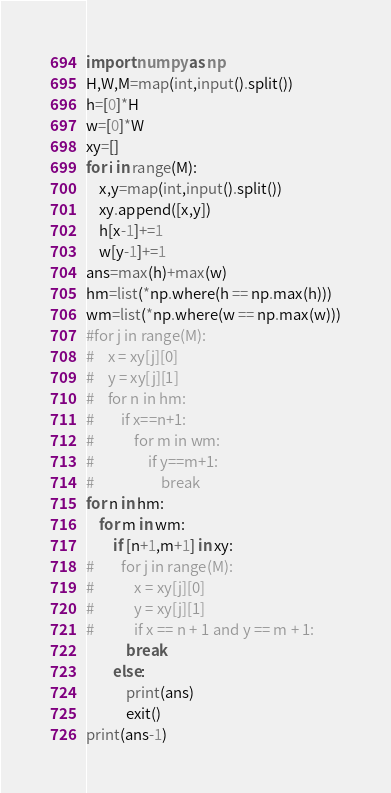<code> <loc_0><loc_0><loc_500><loc_500><_Python_>import numpy as np
H,W,M=map(int,input().split())
h=[0]*H
w=[0]*W
xy=[]
for i in range(M):
    x,y=map(int,input().split())
    xy.append([x,y])
    h[x-1]+=1
    w[y-1]+=1
ans=max(h)+max(w)
hm=list(*np.where(h == np.max(h)))
wm=list(*np.where(w == np.max(w)))
#for j in range(M):
#    x = xy[j][0]
#    y = xy[j][1]
#    for n in hm:
#        if x==n+1:
#            for m in wm:
#                if y==m+1:
#                    break
for n in hm:
    for m in wm:
        if [n+1,m+1] in xy:
#        for j in range(M):
#            x = xy[j][0]
#            y = xy[j][1]
#            if x == n + 1 and y == m + 1:
            break
        else:
            print(ans)
            exit()
print(ans-1)</code> 